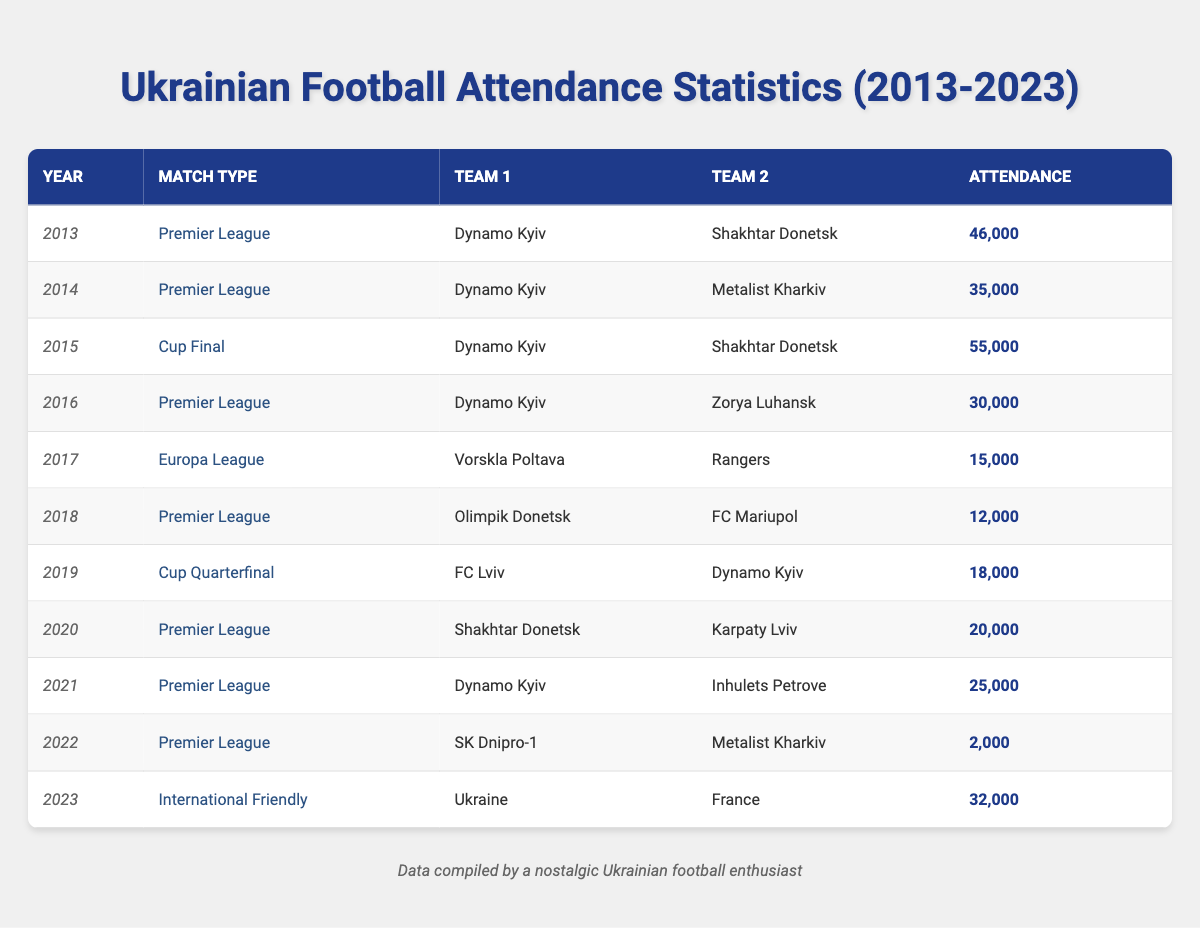What was the highest attendance recorded in the table? The highest attendance listed is for the Cup Final match between Dynamo Kyiv and Shakhtar Donetsk in 2015, which had an attendance of 55,000.
Answer: 55,000 In which year did SK Dnipro-1 have the lowest attendance? SK Dnipro-1 had the lowest attendance in 2022 during a Premier League match against Metalist Kharkiv, with only 2,000 attendees.
Answer: 2,000 Calculate the average attendance for Premier League matches listed in the table. The Premier League attendances are 46,000 (2013), 35,000 (2014), 30,000 (2016), 12,000 (2018), 20,000 (2020), and 25,000 (2021). Summing these gives 46,000 + 35,000 + 30,000 + 12,000 + 20,000 + 25,000 = 168,000. There are 6 data points, so the average is 168,000 / 6 = 28,000.
Answer: 28,000 Did any match in 2017 have an attendance over 20,000? In 2017, the match was between Vorskla Poltava and Rangers, which recorded an attendance of 15,000. Therefore, there were no matches with attendance over 20,000 that year.
Answer: No Which teams played together in 2019 and what was the attendance? FC Lviv and Dynamo Kyiv played against each other in 2019 during a Cup Quarterfinal, and the attendance for that match was 18,000.
Answer: FC Lviv, Dynamo Kyiv, 18,000 What is the difference in attendance between the 2015 Cup Final and the 2022 Premier League match? The attendance for the 2015 Cup Final was 55,000, while for the 2022 Premier League match, it was only 2,000. The difference is 55,000 - 2,000 = 53,000.
Answer: 53,000 Was there a decline in attendance for Premier League matches from 2016 to 2021? The attendance numbers from 2016 to 2021 are 30,000 (2016), 20,000 (2020), and 25,000 (2021). There is not a consistent decline since 2020 had lower attendance than 2016 but improved in 2021. So, the attendance did not decline every year.
Answer: No What was the total attendance for matches in 2018? In 2018, there was only one match listed, which was the Premier League match between Olimpik Donetsk and FC Mariupol, with an attendance of 12,000. So, the total attendance for 2018 is simply 12,000.
Answer: 12,000 In which match did Ukraine play against France, and what was the attendance? Ukraine played against France in an international friendly match in 2023, which recorded an attendance of 32,000.
Answer: Ukraine vs France, 32,000 